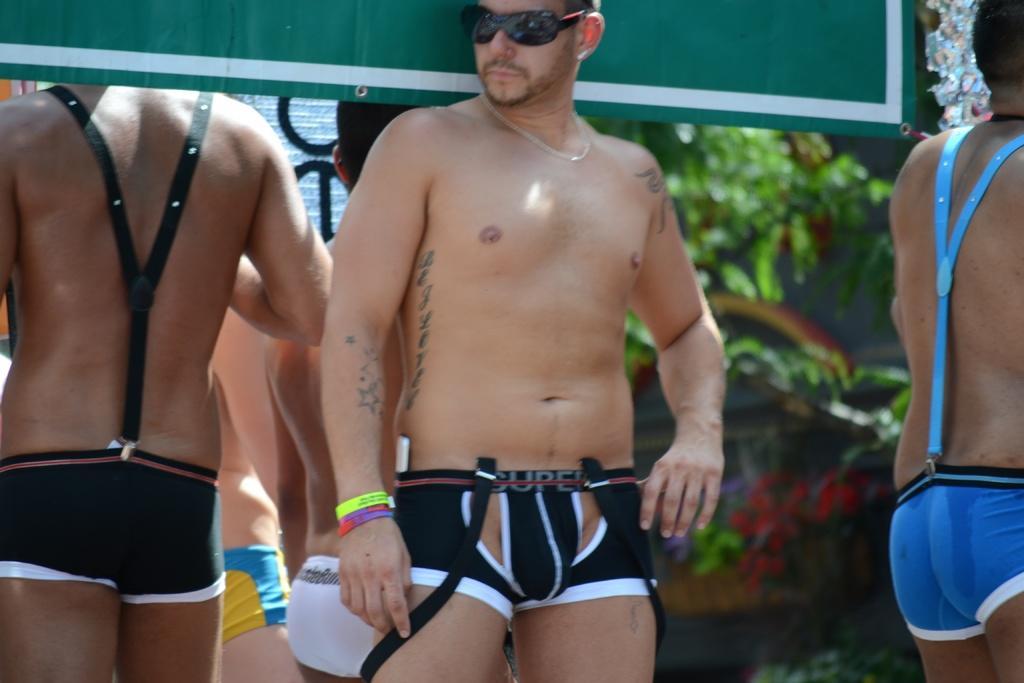Can you describe this image briefly? In this picture we can see some people standing and in the background we can see leaves, some objects and it is blurry. 